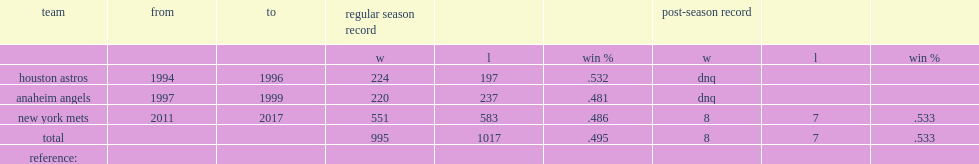Wha is terry collins regular season record during his angels career? 220.0 237.0. 